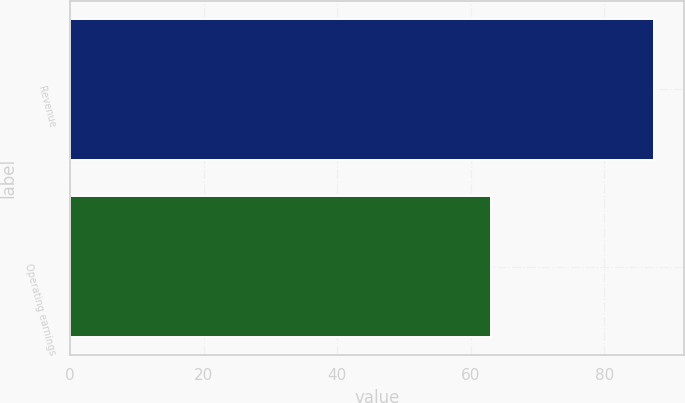Convert chart. <chart><loc_0><loc_0><loc_500><loc_500><bar_chart><fcel>Revenue<fcel>Operating earnings<nl><fcel>87.5<fcel>63<nl></chart> 